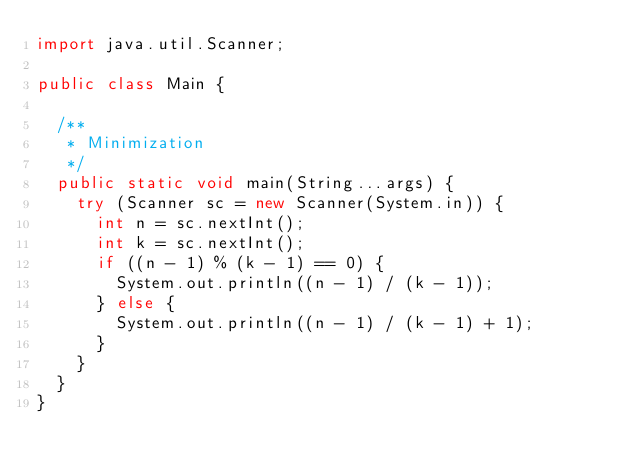<code> <loc_0><loc_0><loc_500><loc_500><_Java_>import java.util.Scanner;

public class Main {

	/**
	 * Minimization
	 */
	public static void main(String...args) {
		try (Scanner sc = new Scanner(System.in)) {
			int n = sc.nextInt();
			int k = sc.nextInt();
			if ((n - 1) % (k - 1) == 0) {
				System.out.println((n - 1) / (k - 1));
			} else {
				System.out.println((n - 1) / (k - 1) + 1);
			}
		}
	}
}</code> 